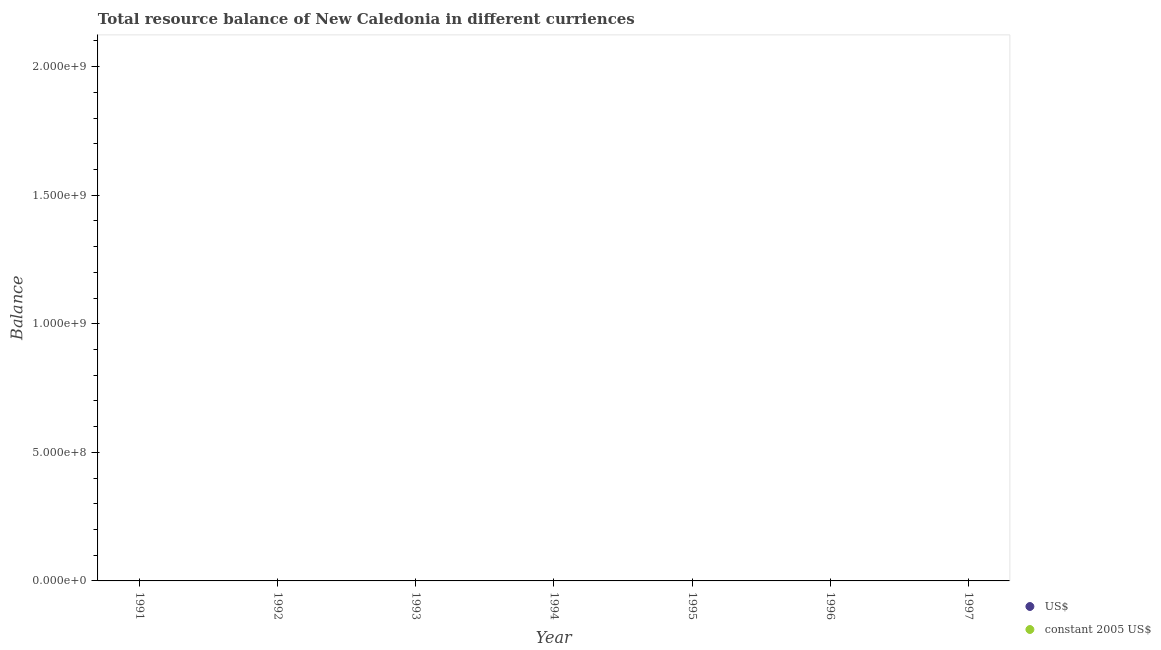Is the number of dotlines equal to the number of legend labels?
Offer a terse response. No. What is the resource balance in us$ in 1996?
Provide a short and direct response. 0. Across all years, what is the minimum resource balance in us$?
Make the answer very short. 0. What is the average resource balance in constant us$ per year?
Give a very brief answer. 0. In how many years, is the resource balance in us$ greater than the average resource balance in us$ taken over all years?
Provide a succinct answer. 0. Is the resource balance in us$ strictly greater than the resource balance in constant us$ over the years?
Provide a short and direct response. Yes. How many years are there in the graph?
Your answer should be very brief. 7. Where does the legend appear in the graph?
Ensure brevity in your answer.  Bottom right. How many legend labels are there?
Keep it short and to the point. 2. What is the title of the graph?
Provide a short and direct response. Total resource balance of New Caledonia in different curriences. What is the label or title of the Y-axis?
Provide a succinct answer. Balance. What is the Balance in US$ in 1991?
Give a very brief answer. 0. What is the Balance in constant 2005 US$ in 1991?
Your response must be concise. 0. What is the Balance of US$ in 1993?
Ensure brevity in your answer.  0. What is the total Balance of US$ in the graph?
Offer a very short reply. 0. 